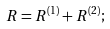Convert formula to latex. <formula><loc_0><loc_0><loc_500><loc_500>R = R ^ { ( 1 ) } + R ^ { ( 2 ) } ;</formula> 